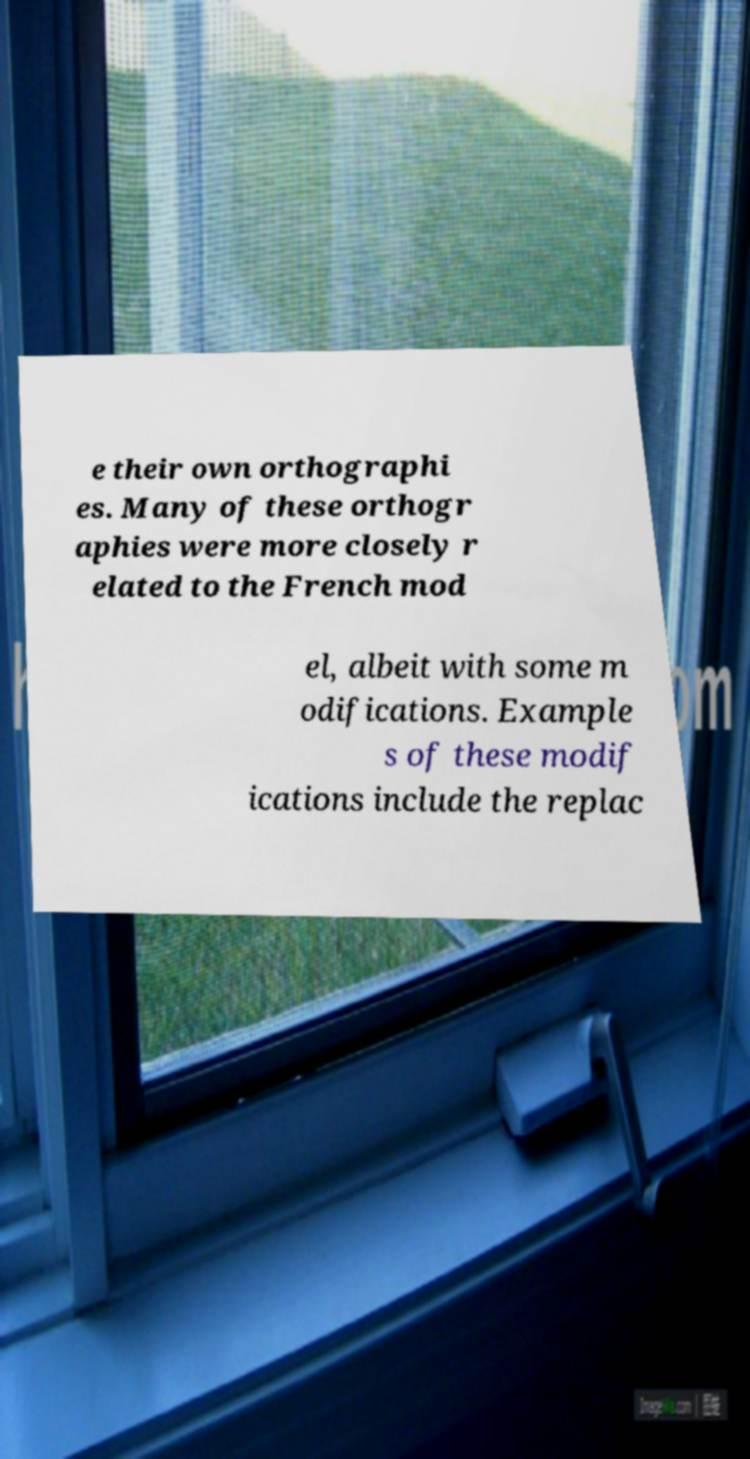Could you assist in decoding the text presented in this image and type it out clearly? e their own orthographi es. Many of these orthogr aphies were more closely r elated to the French mod el, albeit with some m odifications. Example s of these modif ications include the replac 